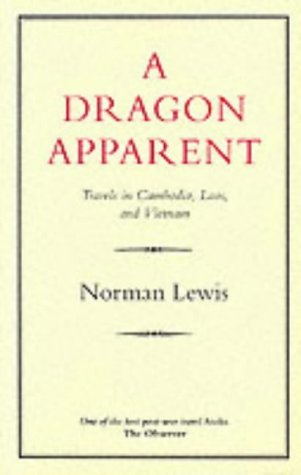What is the title of this book? The title of the book is 'A Dragon Apparent'. It is a renowned travel narrative that delves into the author's journeys through Cambodia, Laos, and Vietnam. 